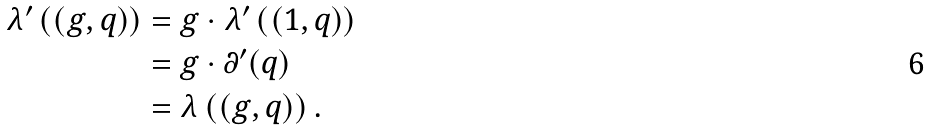<formula> <loc_0><loc_0><loc_500><loc_500>\lambda ^ { \prime } \left ( ( g , q ) \right ) & = g \cdot \lambda ^ { \prime } \left ( ( 1 , q ) \right ) \\ & = g \cdot \partial ^ { \prime } ( q ) \\ & = \lambda \left ( ( g , q ) \right ) .</formula> 